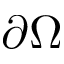<formula> <loc_0><loc_0><loc_500><loc_500>\partial \Omega</formula> 